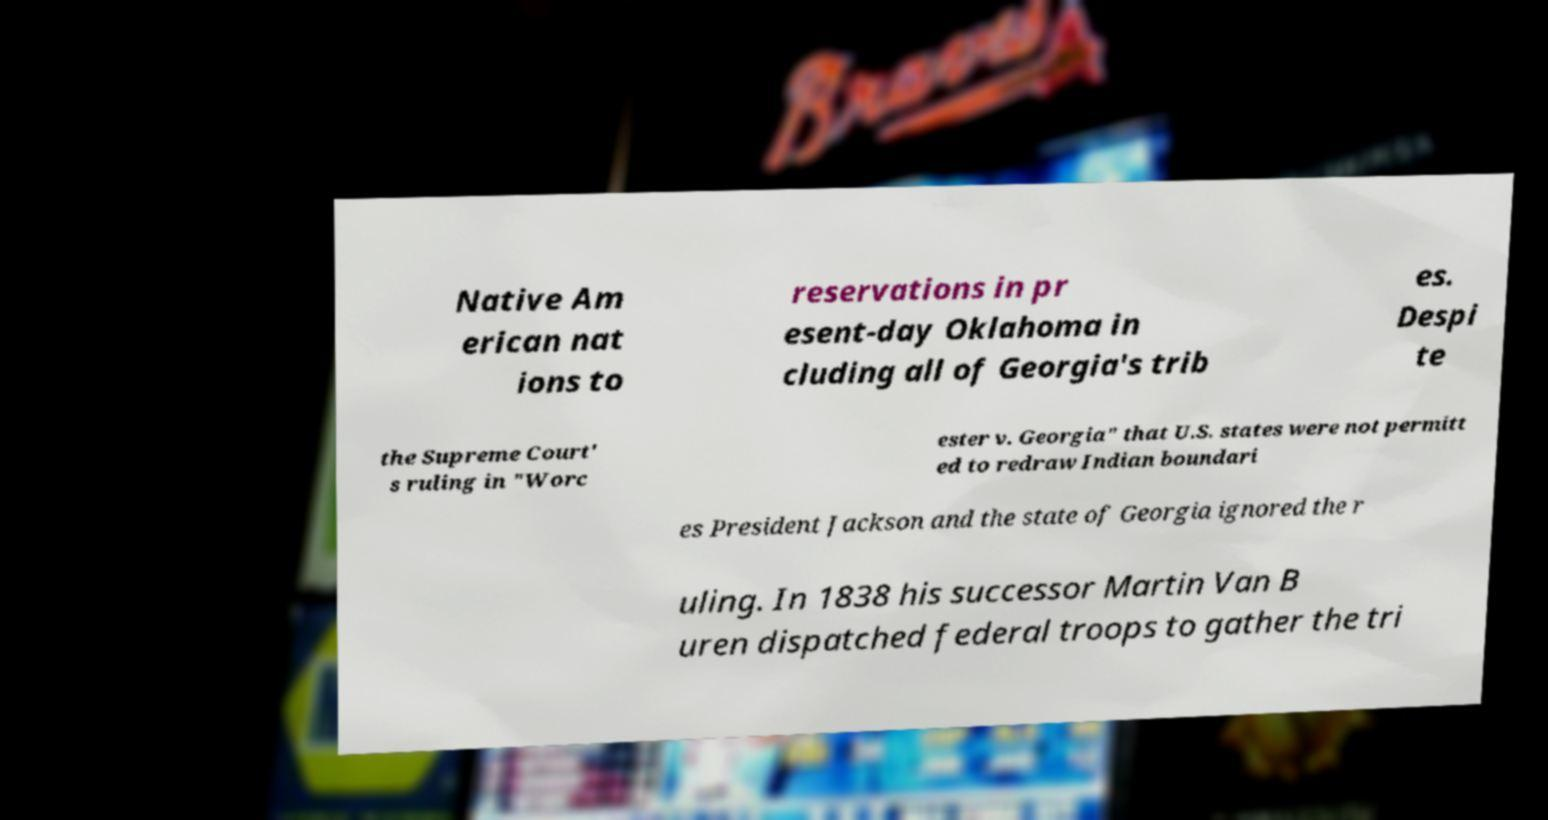Could you assist in decoding the text presented in this image and type it out clearly? Native Am erican nat ions to reservations in pr esent-day Oklahoma in cluding all of Georgia's trib es. Despi te the Supreme Court' s ruling in "Worc ester v. Georgia" that U.S. states were not permitt ed to redraw Indian boundari es President Jackson and the state of Georgia ignored the r uling. In 1838 his successor Martin Van B uren dispatched federal troops to gather the tri 